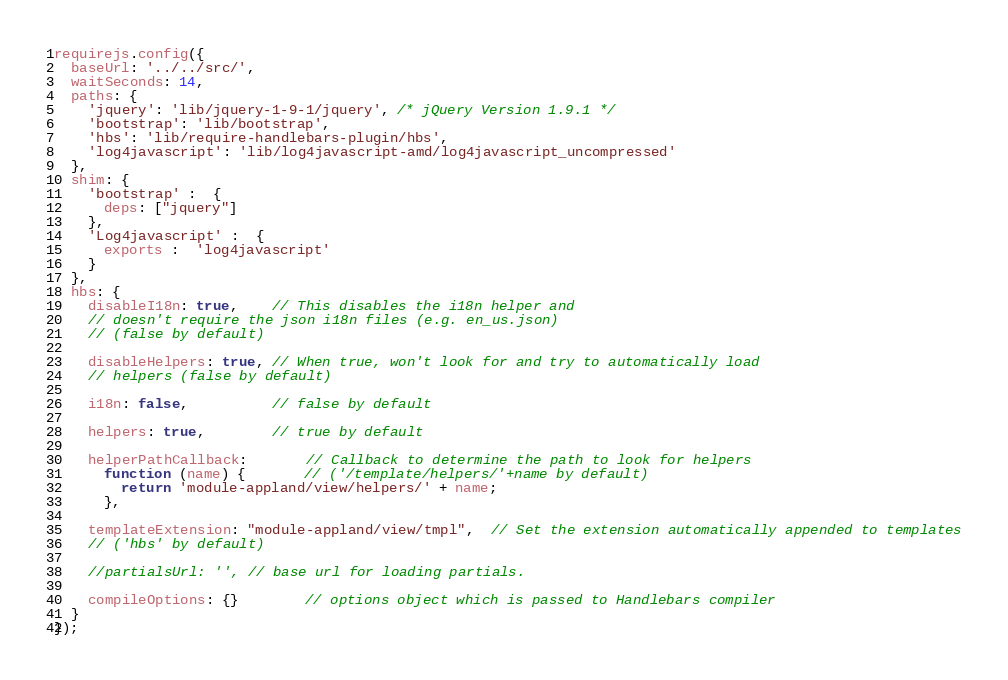<code> <loc_0><loc_0><loc_500><loc_500><_JavaScript_>requirejs.config({
  baseUrl: '../../src/',
  waitSeconds: 14,
  paths: {
    'jquery': 'lib/jquery-1-9-1/jquery', /* jQuery Version 1.9.1 */
    'bootstrap': 'lib/bootstrap',
    'hbs': 'lib/require-handlebars-plugin/hbs',
    'log4javascript': 'lib/log4javascript-amd/log4javascript_uncompressed'
  },
  shim: {
    'bootstrap' :  {
      deps: ["jquery"]
    },
    'Log4javascript' :  {
      exports :  'log4javascript'
    }
  },
  hbs: {
    disableI18n: true,    // This disables the i18n helper and
    // doesn't require the json i18n files (e.g. en_us.json)
    // (false by default)

    disableHelpers: true, // When true, won't look for and try to automatically load
    // helpers (false by default)

    i18n: false,          // false by default

    helpers: true,        // true by default

    helperPathCallback:       // Callback to determine the path to look for helpers
      function (name) {       // ('/template/helpers/'+name by default)
        return 'module-appland/view/helpers/' + name;
      },

    templateExtension: "module-appland/view/tmpl",  // Set the extension automatically appended to templates
    // ('hbs' by default)

    //partialsUrl: '', // base url for loading partials.

    compileOptions: {}        // options object which is passed to Handlebars compiler
  }
});</code> 